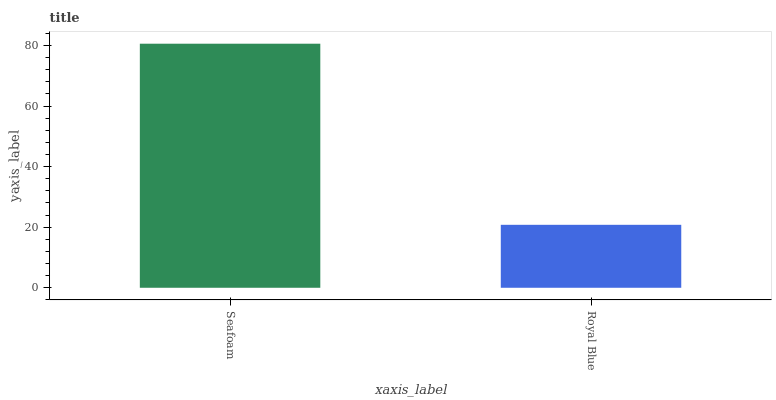Is Royal Blue the minimum?
Answer yes or no. Yes. Is Seafoam the maximum?
Answer yes or no. Yes. Is Royal Blue the maximum?
Answer yes or no. No. Is Seafoam greater than Royal Blue?
Answer yes or no. Yes. Is Royal Blue less than Seafoam?
Answer yes or no. Yes. Is Royal Blue greater than Seafoam?
Answer yes or no. No. Is Seafoam less than Royal Blue?
Answer yes or no. No. Is Seafoam the high median?
Answer yes or no. Yes. Is Royal Blue the low median?
Answer yes or no. Yes. Is Royal Blue the high median?
Answer yes or no. No. Is Seafoam the low median?
Answer yes or no. No. 